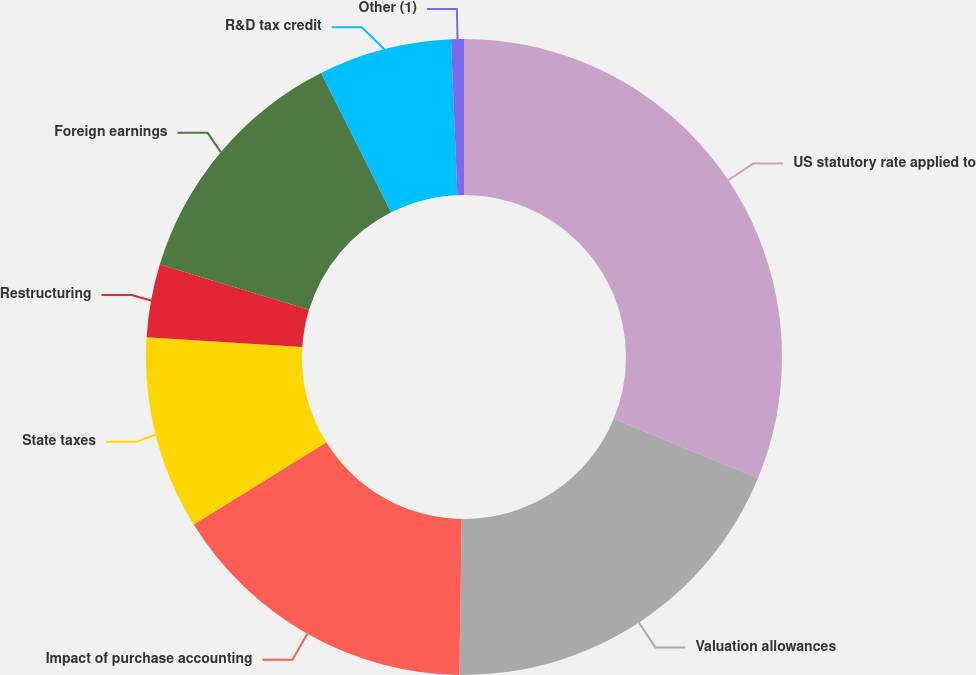<chart> <loc_0><loc_0><loc_500><loc_500><pie_chart><fcel>US statutory rate applied to<fcel>Valuation allowances<fcel>Impact of purchase accounting<fcel>State taxes<fcel>Restructuring<fcel>Foreign earnings<fcel>R&D tax credit<fcel>Other (1)<nl><fcel>31.23%<fcel>19.0%<fcel>15.94%<fcel>9.82%<fcel>3.71%<fcel>12.88%<fcel>6.77%<fcel>0.65%<nl></chart> 